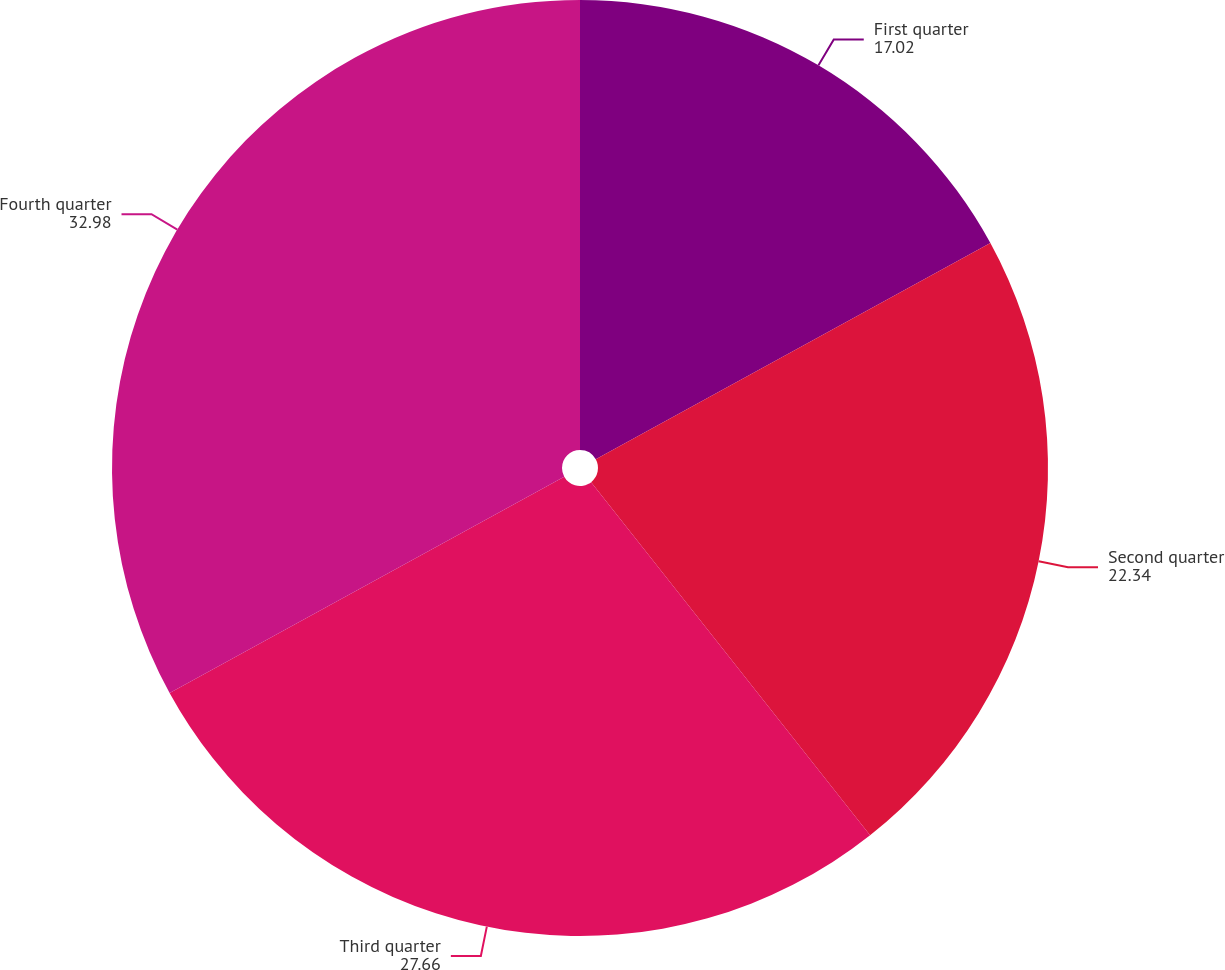<chart> <loc_0><loc_0><loc_500><loc_500><pie_chart><fcel>First quarter<fcel>Second quarter<fcel>Third quarter<fcel>Fourth quarter<nl><fcel>17.02%<fcel>22.34%<fcel>27.66%<fcel>32.98%<nl></chart> 